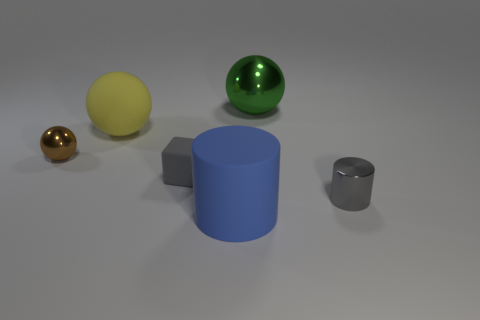Add 4 cyan shiny spheres. How many objects exist? 10 Subtract all blocks. How many objects are left? 5 Add 2 brown shiny things. How many brown shiny things are left? 3 Add 4 large green objects. How many large green objects exist? 5 Subtract 0 red blocks. How many objects are left? 6 Subtract all rubber cylinders. Subtract all metal spheres. How many objects are left? 3 